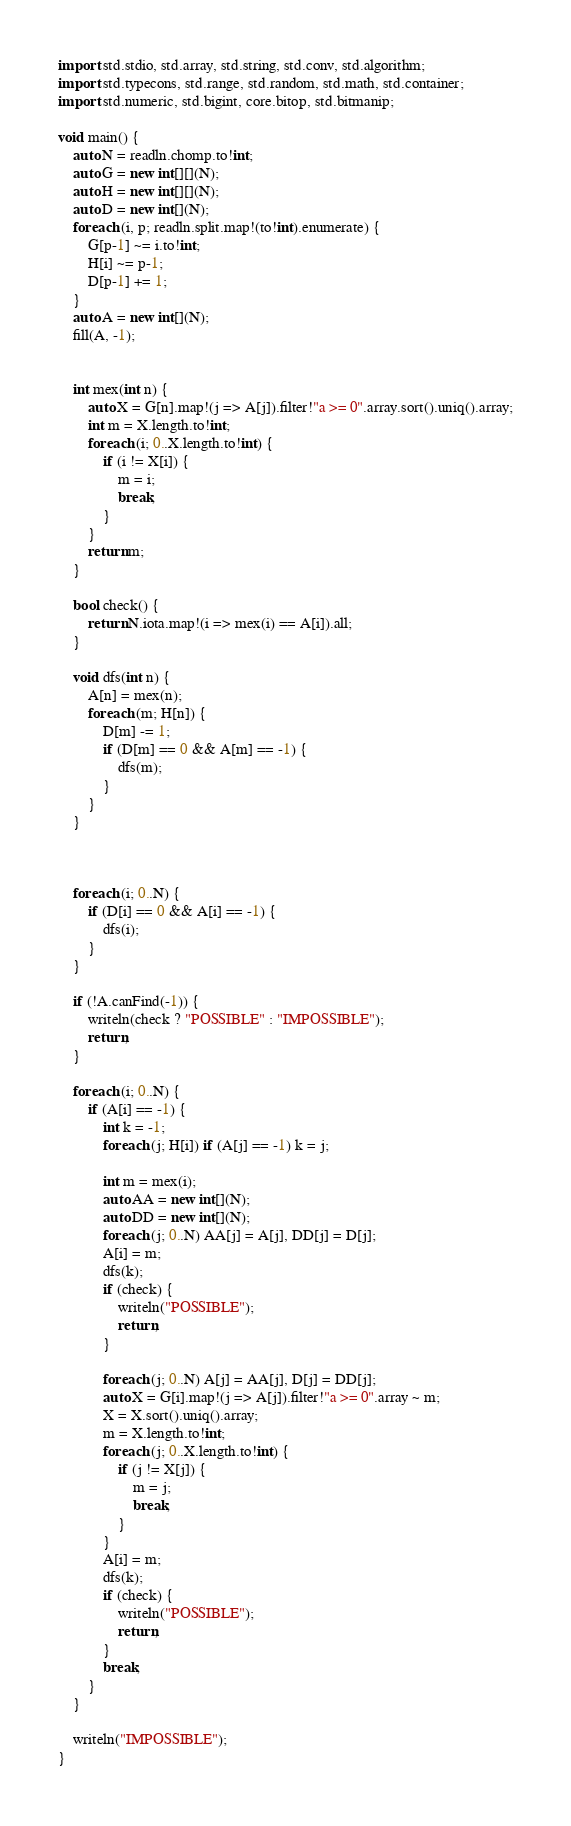<code> <loc_0><loc_0><loc_500><loc_500><_D_>import std.stdio, std.array, std.string, std.conv, std.algorithm;
import std.typecons, std.range, std.random, std.math, std.container;
import std.numeric, std.bigint, core.bitop, std.bitmanip;

void main() {
    auto N = readln.chomp.to!int;
    auto G = new int[][](N);
    auto H = new int[][](N);
    auto D = new int[](N);
    foreach (i, p; readln.split.map!(to!int).enumerate) {
        G[p-1] ~= i.to!int;
        H[i] ~= p-1;
        D[p-1] += 1;
    }
    auto A = new int[](N);
    fill(A, -1);

    
    int mex(int n) {
        auto X = G[n].map!(j => A[j]).filter!"a >= 0".array.sort().uniq().array;
        int m = X.length.to!int;
        foreach (i; 0..X.length.to!int) {
            if (i != X[i]) {
                m = i;
                break;
            }
        }
        return m;
    }

    bool check() {
        return N.iota.map!(i => mex(i) == A[i]).all;
    }
    
    void dfs(int n) {
        A[n] = mex(n);
        foreach (m; H[n]) {
            D[m] -= 1;
            if (D[m] == 0 && A[m] == -1) {
                dfs(m);
            }
        }
    }


    
    foreach (i; 0..N) {
        if (D[i] == 0 && A[i] == -1) {
            dfs(i);
        }
    }

    if (!A.canFind(-1)) {
        writeln(check ? "POSSIBLE" : "IMPOSSIBLE");
        return;
    }

    foreach (i; 0..N) {
        if (A[i] == -1) {
            int k = -1;
            foreach (j; H[i]) if (A[j] == -1) k = j;
            
            int m = mex(i);
            auto AA = new int[](N);
            auto DD = new int[](N);
            foreach (j; 0..N) AA[j] = A[j], DD[j] = D[j];
            A[i] = m;
            dfs(k);
            if (check) {
                writeln("POSSIBLE");
                return;
            }
            
            foreach (j; 0..N) A[j] = AA[j], D[j] = DD[j];
            auto X = G[i].map!(j => A[j]).filter!"a >= 0".array ~ m;
            X = X.sort().uniq().array;
            m = X.length.to!int;
            foreach (j; 0..X.length.to!int) {
                if (j != X[j]) {
                    m = j;
                    break;
                }
            }
            A[i] = m;
            dfs(k);
            if (check) {
                writeln("POSSIBLE");
                return;
            }
            break;
        }
    }

    writeln("IMPOSSIBLE");
}

</code> 